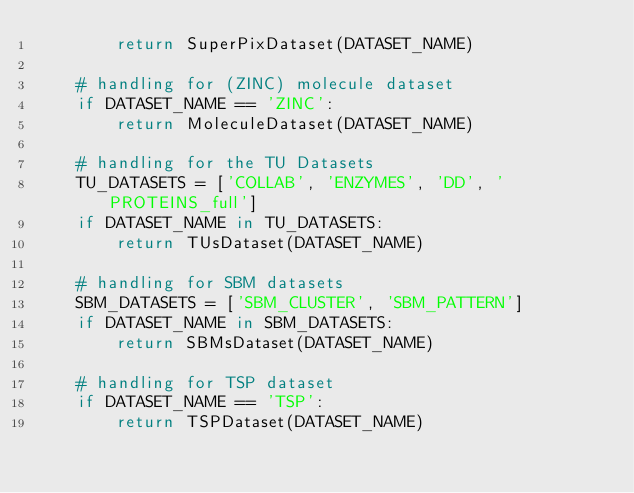Convert code to text. <code><loc_0><loc_0><loc_500><loc_500><_Python_>        return SuperPixDataset(DATASET_NAME)
    
    # handling for (ZINC) molecule dataset
    if DATASET_NAME == 'ZINC':
        return MoleculeDataset(DATASET_NAME)

    # handling for the TU Datasets
    TU_DATASETS = ['COLLAB', 'ENZYMES', 'DD', 'PROTEINS_full']
    if DATASET_NAME in TU_DATASETS: 
        return TUsDataset(DATASET_NAME)

    # handling for SBM datasets
    SBM_DATASETS = ['SBM_CLUSTER', 'SBM_PATTERN']
    if DATASET_NAME in SBM_DATASETS: 
        return SBMsDataset(DATASET_NAME)
    
    # handling for TSP dataset
    if DATASET_NAME == 'TSP':
        return TSPDataset(DATASET_NAME)
</code> 